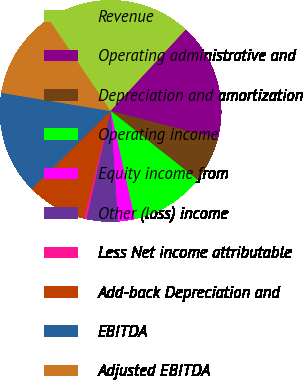<chart> <loc_0><loc_0><loc_500><loc_500><pie_chart><fcel>Revenue<fcel>Operating administrative and<fcel>Depreciation and amortization<fcel>Operating income<fcel>Equity income from<fcel>Other (loss) income<fcel>Less Net income attributable<fcel>Add-back Depreciation and<fcel>EBITDA<fcel>Adjusted EBITDA<nl><fcel>21.32%<fcel>17.13%<fcel>6.65%<fcel>10.84%<fcel>2.45%<fcel>4.55%<fcel>0.35%<fcel>8.74%<fcel>15.03%<fcel>12.94%<nl></chart> 